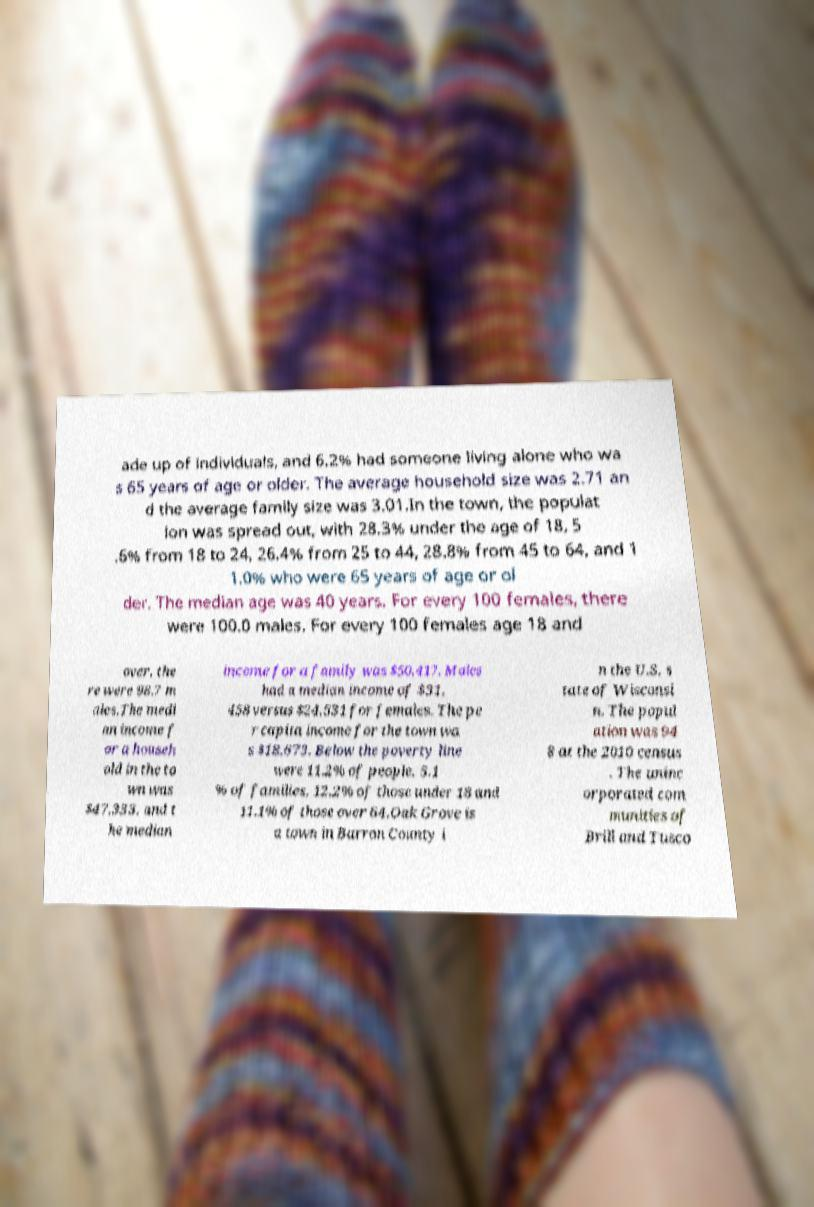For documentation purposes, I need the text within this image transcribed. Could you provide that? ade up of individuals, and 6.2% had someone living alone who wa s 65 years of age or older. The average household size was 2.71 an d the average family size was 3.01.In the town, the populat ion was spread out, with 28.3% under the age of 18, 5 .6% from 18 to 24, 26.4% from 25 to 44, 28.8% from 45 to 64, and 1 1.0% who were 65 years of age or ol der. The median age was 40 years. For every 100 females, there were 100.0 males. For every 100 females age 18 and over, the re were 98.7 m ales.The medi an income f or a househ old in the to wn was $47,333, and t he median income for a family was $50,417. Males had a median income of $31, 458 versus $24,531 for females. The pe r capita income for the town wa s $18,673. Below the poverty line were 11.2% of people, 5.1 % of families, 12.2% of those under 18 and 11.1% of those over 64.Oak Grove is a town in Barron County i n the U.S. s tate of Wisconsi n. The popul ation was 94 8 at the 2010 census . The uninc orporated com munities of Brill and Tusco 